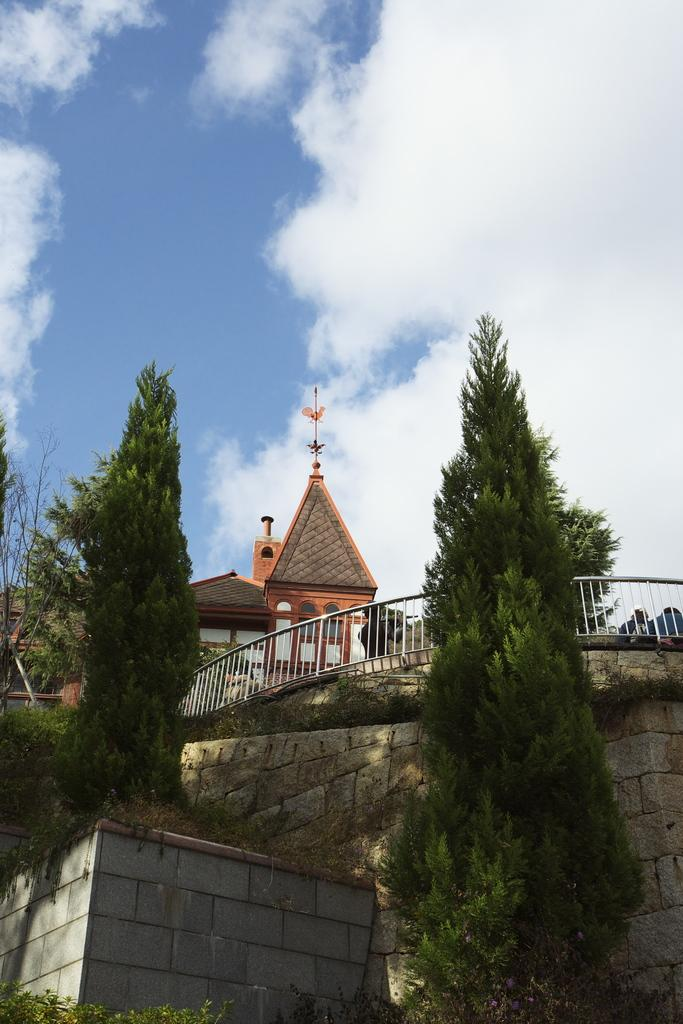What type of structures are located in the center of the image? There are houses in the center of the image. What can be seen in the foreground of the image? There are trees and a wall in the foreground of the image. What type of barrier is also present in the foreground of the image? There is a fence in the foreground of the image. What is visible at the top of the image? The sky is visible at the top of the image. How many pigs are standing on the wall in the image? There are no pigs present in the image; the wall is empty. What direction is the pig pointing in the image? There is no pig present in the image, so it cannot be determined which direction it might be pointing. 